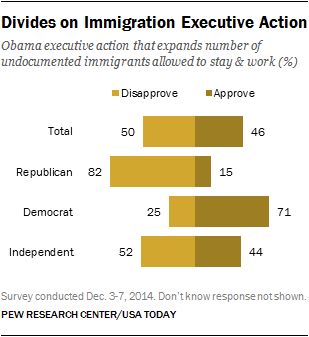List a handful of essential elements in this visual. The approval rate for Total is higher than that of Independent. The two-color bar represents either approval or disapproval. 